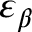Convert formula to latex. <formula><loc_0><loc_0><loc_500><loc_500>\varepsilon _ { \beta }</formula> 